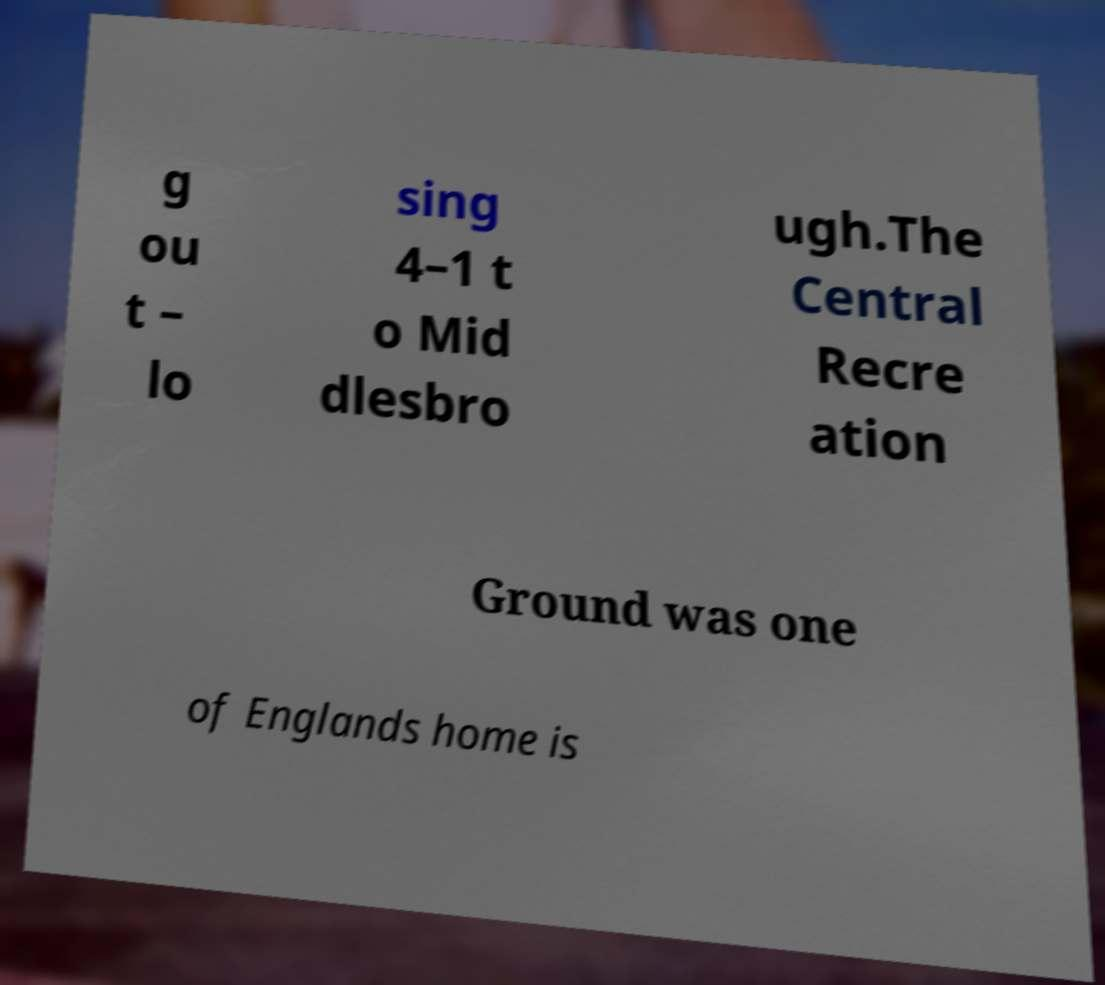Please identify and transcribe the text found in this image. g ou t – lo sing 4–1 t o Mid dlesbro ugh.The Central Recre ation Ground was one of Englands home is 